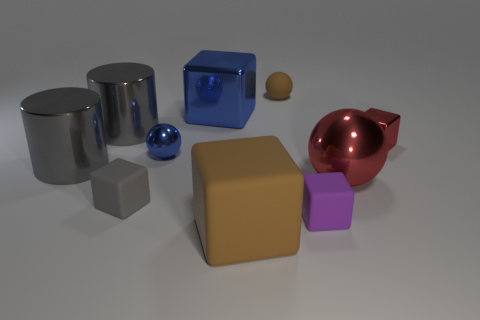Subtract all blue blocks. How many blocks are left? 4 Subtract 3 blocks. How many blocks are left? 2 Subtract all big shiny cubes. How many cubes are left? 4 Subtract all cyan blocks. Subtract all cyan cylinders. How many blocks are left? 5 Subtract all cylinders. How many objects are left? 8 Subtract 0 gray spheres. How many objects are left? 10 Subtract all tiny brown matte spheres. Subtract all tiny cyan rubber objects. How many objects are left? 9 Add 2 large blue objects. How many large blue objects are left? 3 Add 3 red blocks. How many red blocks exist? 4 